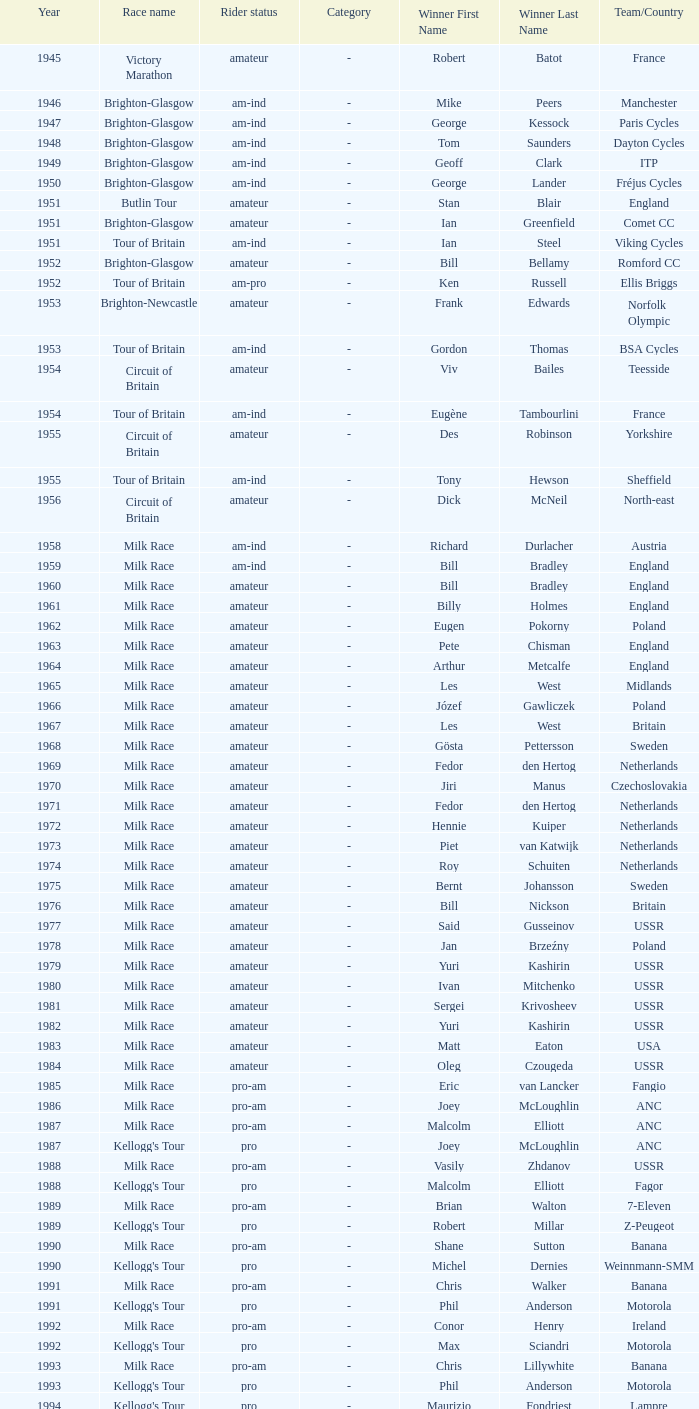What is the rider status for the 1971 netherlands team? Amateur. 